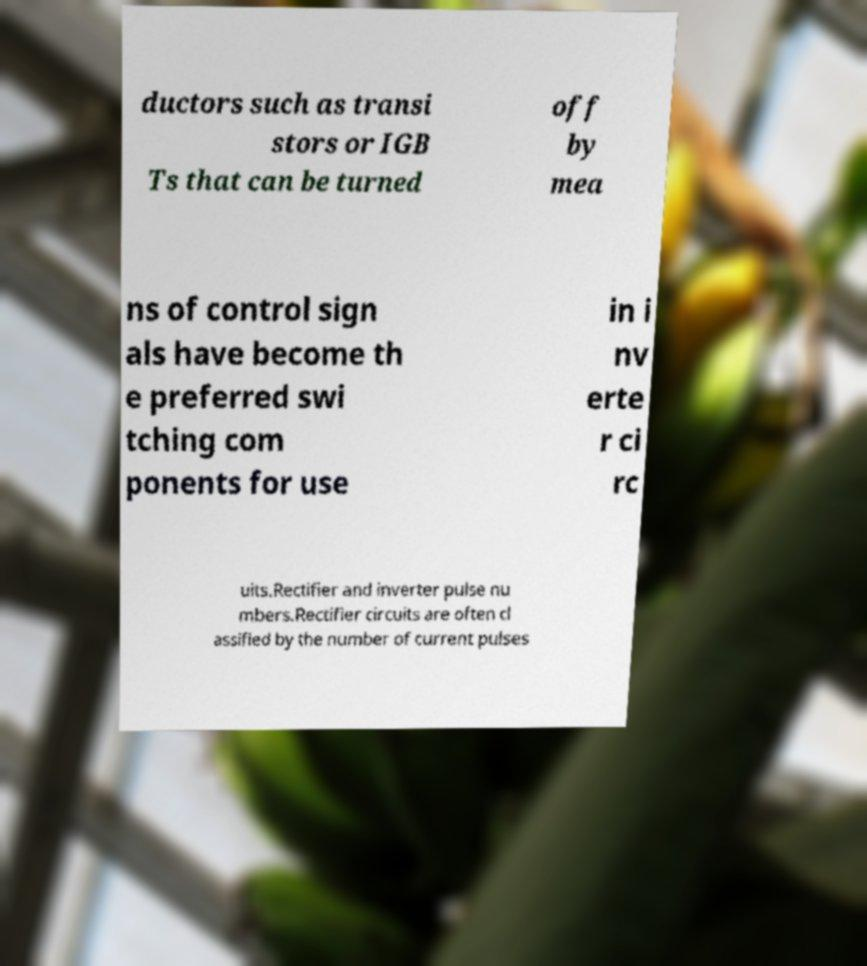For documentation purposes, I need the text within this image transcribed. Could you provide that? ductors such as transi stors or IGB Ts that can be turned off by mea ns of control sign als have become th e preferred swi tching com ponents for use in i nv erte r ci rc uits.Rectifier and inverter pulse nu mbers.Rectifier circuits are often cl assified by the number of current pulses 